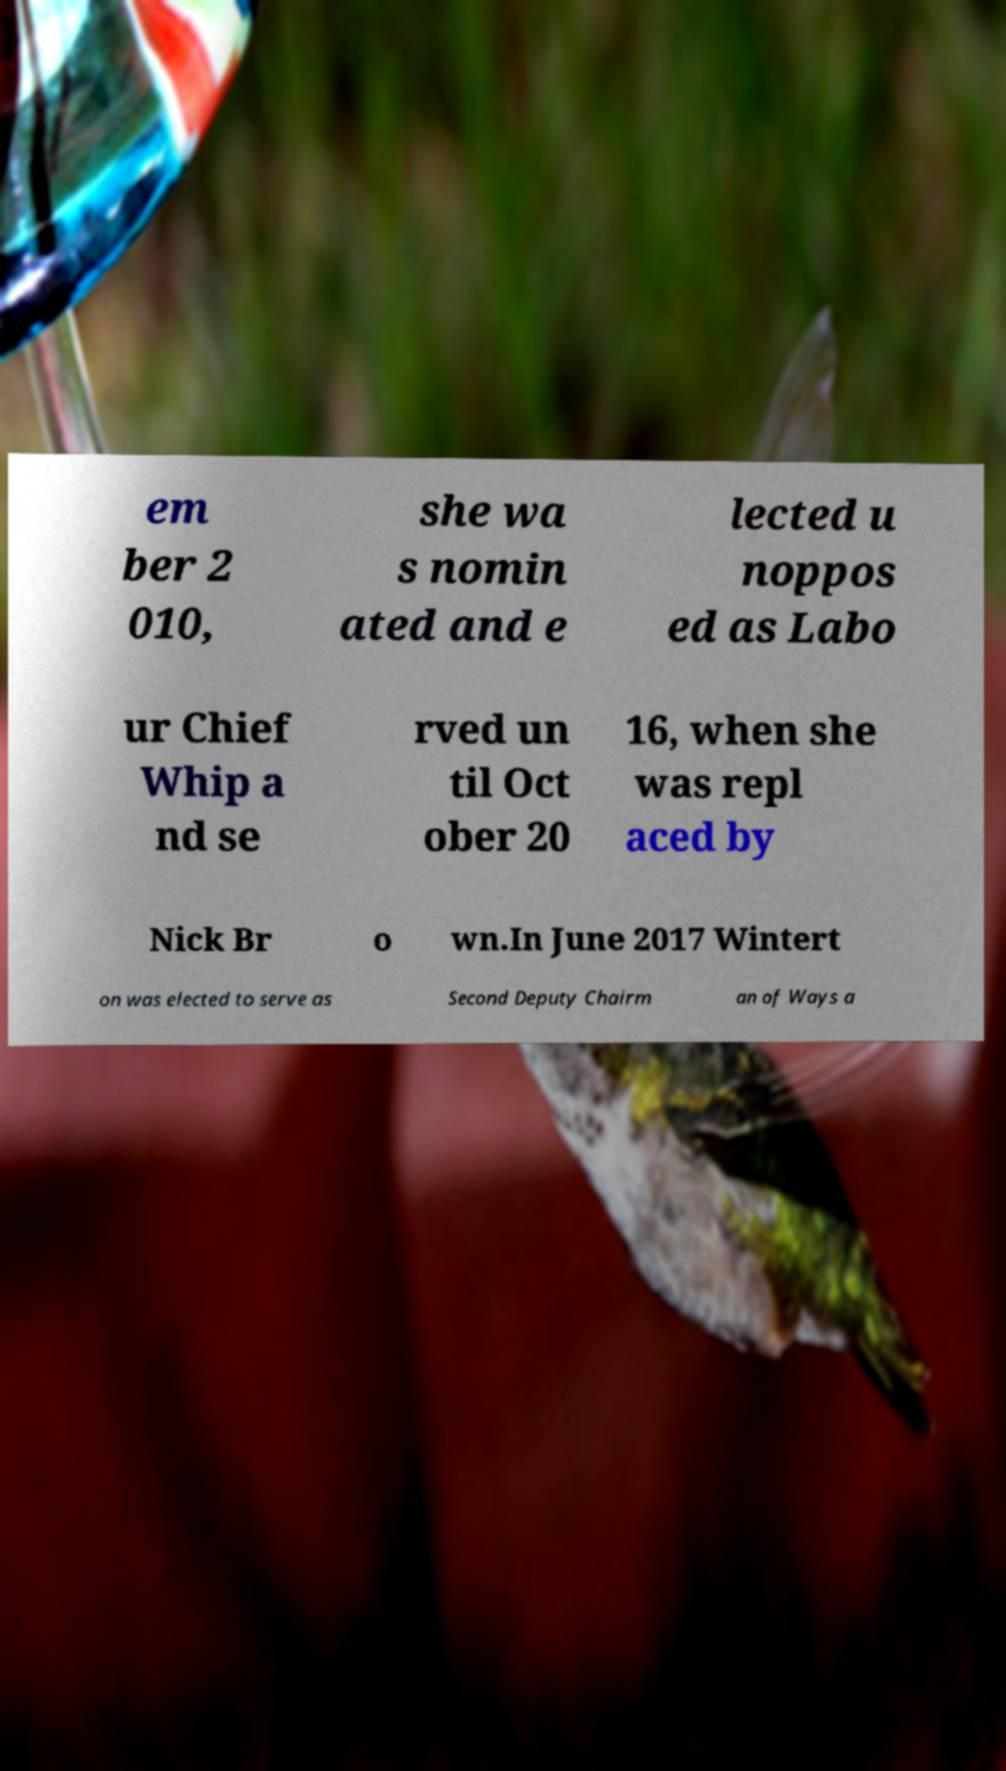For documentation purposes, I need the text within this image transcribed. Could you provide that? em ber 2 010, she wa s nomin ated and e lected u noppos ed as Labo ur Chief Whip a nd se rved un til Oct ober 20 16, when she was repl aced by Nick Br o wn.In June 2017 Wintert on was elected to serve as Second Deputy Chairm an of Ways a 